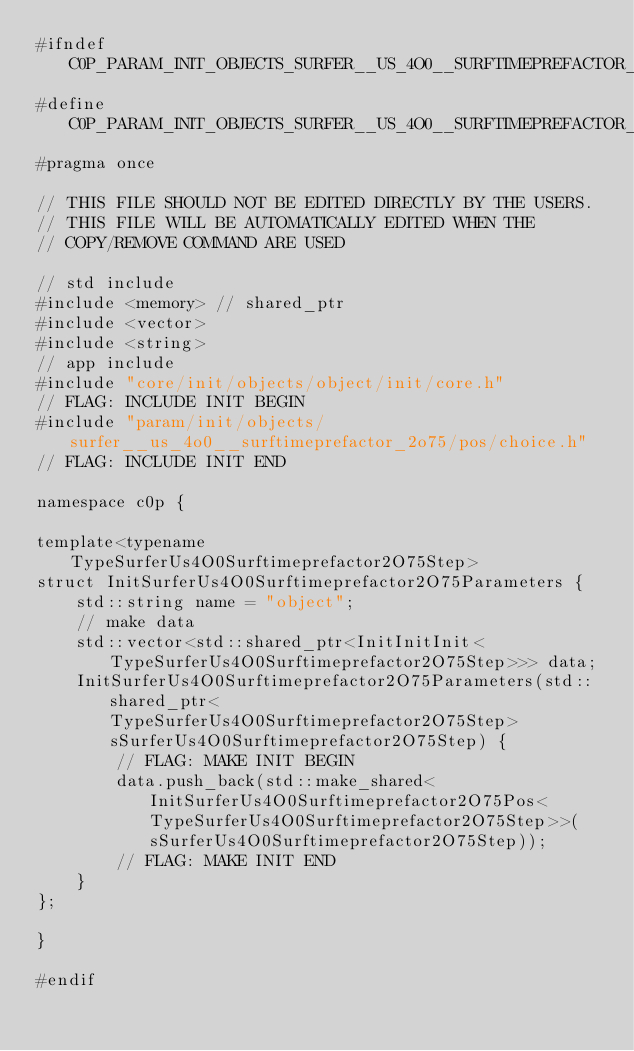<code> <loc_0><loc_0><loc_500><loc_500><_C_>#ifndef C0P_PARAM_INIT_OBJECTS_SURFER__US_4O0__SURFTIMEPREFACTOR_2O75_PARAMETERS_H
#define C0P_PARAM_INIT_OBJECTS_SURFER__US_4O0__SURFTIMEPREFACTOR_2O75_PARAMETERS_H
#pragma once

// THIS FILE SHOULD NOT BE EDITED DIRECTLY BY THE USERS.
// THIS FILE WILL BE AUTOMATICALLY EDITED WHEN THE
// COPY/REMOVE COMMAND ARE USED

// std include
#include <memory> // shared_ptr
#include <vector>
#include <string>
// app include
#include "core/init/objects/object/init/core.h"
// FLAG: INCLUDE INIT BEGIN
#include "param/init/objects/surfer__us_4o0__surftimeprefactor_2o75/pos/choice.h"
// FLAG: INCLUDE INIT END

namespace c0p {

template<typename TypeSurferUs4O0Surftimeprefactor2O75Step>
struct InitSurferUs4O0Surftimeprefactor2O75Parameters {
    std::string name = "object";
    // make data
    std::vector<std::shared_ptr<InitInitInit<TypeSurferUs4O0Surftimeprefactor2O75Step>>> data;
    InitSurferUs4O0Surftimeprefactor2O75Parameters(std::shared_ptr<TypeSurferUs4O0Surftimeprefactor2O75Step> sSurferUs4O0Surftimeprefactor2O75Step) {
        // FLAG: MAKE INIT BEGIN
        data.push_back(std::make_shared<InitSurferUs4O0Surftimeprefactor2O75Pos<TypeSurferUs4O0Surftimeprefactor2O75Step>>(sSurferUs4O0Surftimeprefactor2O75Step));
        // FLAG: MAKE INIT END
    }
};

}

#endif
</code> 